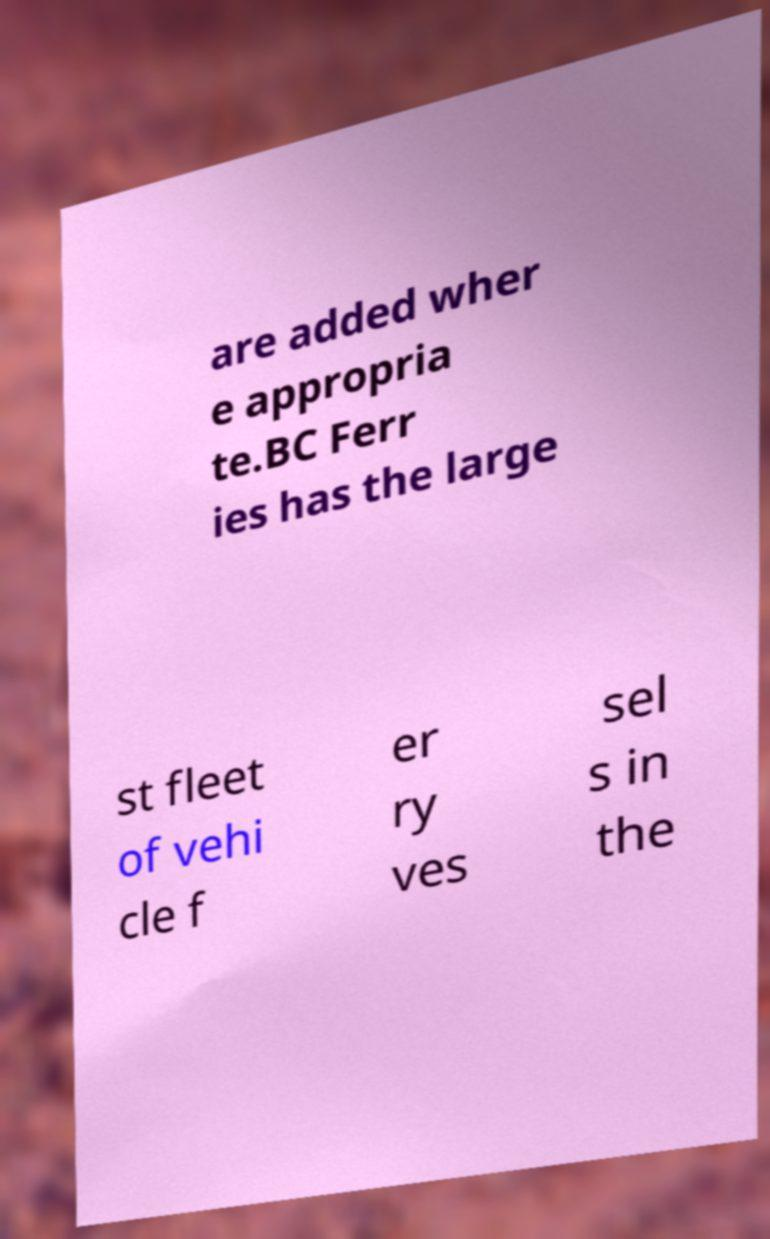Could you assist in decoding the text presented in this image and type it out clearly? are added wher e appropria te.BC Ferr ies has the large st fleet of vehi cle f er ry ves sel s in the 